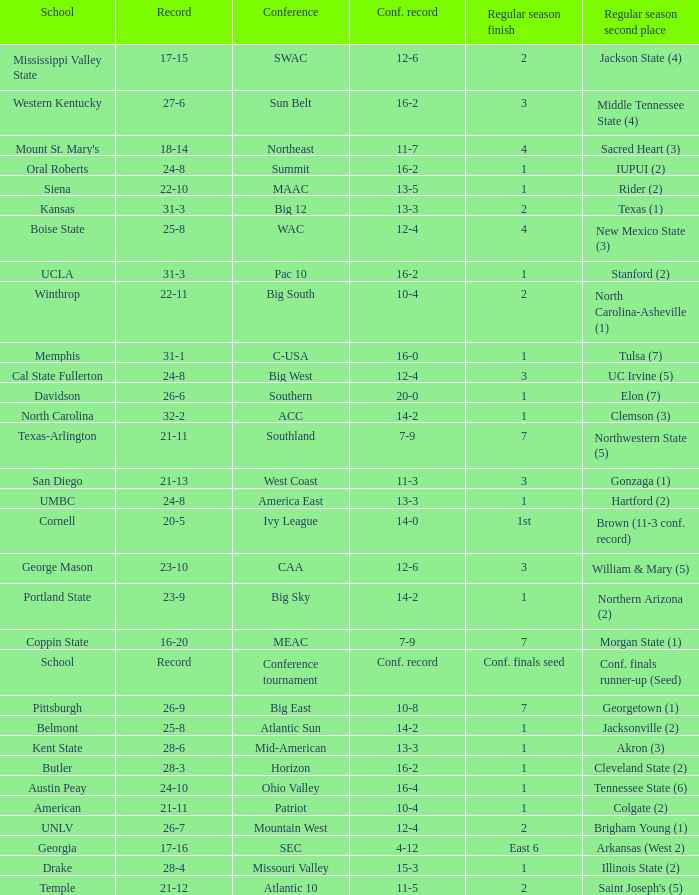What was the overall record of UMBC? 24-8. Would you be able to parse every entry in this table? {'header': ['School', 'Record', 'Conference', 'Conf. record', 'Regular season finish', 'Regular season second place'], 'rows': [['Mississippi Valley State', '17-15', 'SWAC', '12-6', '2', 'Jackson State (4)'], ['Western Kentucky', '27-6', 'Sun Belt', '16-2', '3', 'Middle Tennessee State (4)'], ["Mount St. Mary's", '18-14', 'Northeast', '11-7', '4', 'Sacred Heart (3)'], ['Oral Roberts', '24-8', 'Summit', '16-2', '1', 'IUPUI (2)'], ['Siena', '22-10', 'MAAC', '13-5', '1', 'Rider (2)'], ['Kansas', '31-3', 'Big 12', '13-3', '2', 'Texas (1)'], ['Boise State', '25-8', 'WAC', '12-4', '4', 'New Mexico State (3)'], ['UCLA', '31-3', 'Pac 10', '16-2', '1', 'Stanford (2)'], ['Winthrop', '22-11', 'Big South', '10-4', '2', 'North Carolina-Asheville (1)'], ['Memphis', '31-1', 'C-USA', '16-0', '1', 'Tulsa (7)'], ['Cal State Fullerton', '24-8', 'Big West', '12-4', '3', 'UC Irvine (5)'], ['Davidson', '26-6', 'Southern', '20-0', '1', 'Elon (7)'], ['North Carolina', '32-2', 'ACC', '14-2', '1', 'Clemson (3)'], ['Texas-Arlington', '21-11', 'Southland', '7-9', '7', 'Northwestern State (5)'], ['San Diego', '21-13', 'West Coast', '11-3', '3', 'Gonzaga (1)'], ['UMBC', '24-8', 'America East', '13-3', '1', 'Hartford (2)'], ['Cornell', '20-5', 'Ivy League', '14-0', '1st', 'Brown (11-3 conf. record)'], ['George Mason', '23-10', 'CAA', '12-6', '3', 'William & Mary (5)'], ['Portland State', '23-9', 'Big Sky', '14-2', '1', 'Northern Arizona (2)'], ['Coppin State', '16-20', 'MEAC', '7-9', '7', 'Morgan State (1)'], ['School', 'Record', 'Conference tournament', 'Conf. record', 'Conf. finals seed', 'Conf. finals runner-up (Seed)'], ['Pittsburgh', '26-9', 'Big East', '10-8', '7', 'Georgetown (1)'], ['Belmont', '25-8', 'Atlantic Sun', '14-2', '1', 'Jacksonville (2)'], ['Kent State', '28-6', 'Mid-American', '13-3', '1', 'Akron (3)'], ['Butler', '28-3', 'Horizon', '16-2', '1', 'Cleveland State (2)'], ['Austin Peay', '24-10', 'Ohio Valley', '16-4', '1', 'Tennessee State (6)'], ['American', '21-11', 'Patriot', '10-4', '1', 'Colgate (2)'], ['UNLV', '26-7', 'Mountain West', '12-4', '2', 'Brigham Young (1)'], ['Georgia', '17-16', 'SEC', '4-12', 'East 6', 'Arkansas (West 2)'], ['Drake', '28-4', 'Missouri Valley', '15-3', '1', 'Illinois State (2)'], ['Temple', '21-12', 'Atlantic 10', '11-5', '2', "Saint Joseph's (5)"]]} 